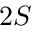Convert formula to latex. <formula><loc_0><loc_0><loc_500><loc_500>2 S</formula> 